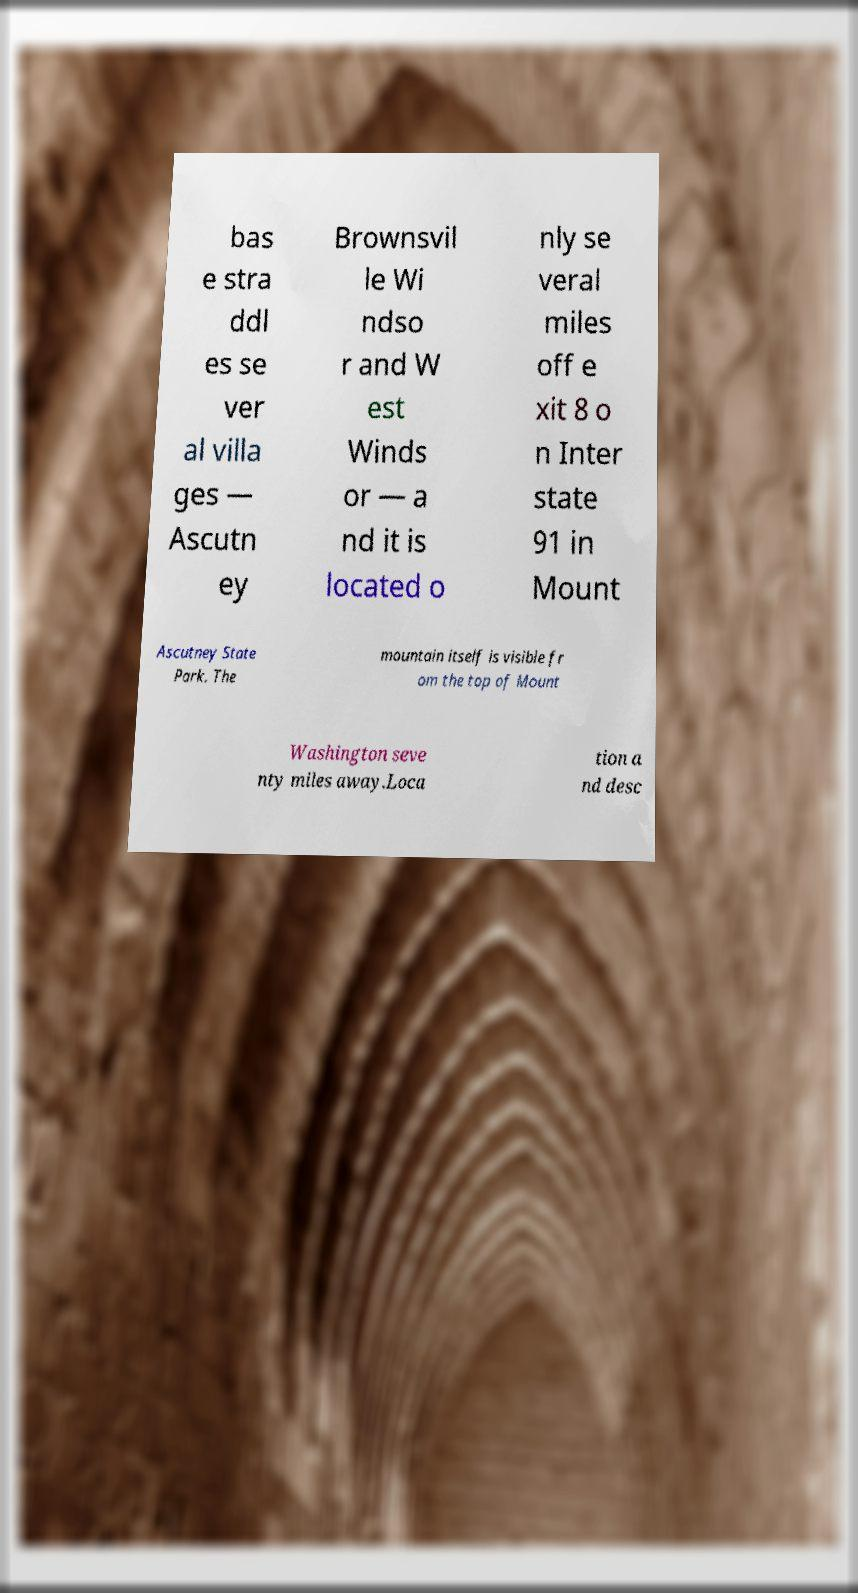Please read and relay the text visible in this image. What does it say? bas e stra ddl es se ver al villa ges — Ascutn ey Brownsvil le Wi ndso r and W est Winds or — a nd it is located o nly se veral miles off e xit 8 o n Inter state 91 in Mount Ascutney State Park. The mountain itself is visible fr om the top of Mount Washington seve nty miles away.Loca tion a nd desc 